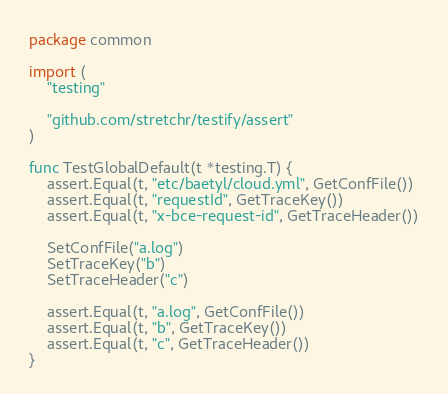Convert code to text. <code><loc_0><loc_0><loc_500><loc_500><_Go_>package common

import (
	"testing"

	"github.com/stretchr/testify/assert"
)

func TestGlobalDefault(t *testing.T) {
	assert.Equal(t, "etc/baetyl/cloud.yml", GetConfFile())
	assert.Equal(t, "requestId", GetTraceKey())
	assert.Equal(t, "x-bce-request-id", GetTraceHeader())

	SetConfFile("a.log")
	SetTraceKey("b")
	SetTraceHeader("c")

	assert.Equal(t, "a.log", GetConfFile())
	assert.Equal(t, "b", GetTraceKey())
	assert.Equal(t, "c", GetTraceHeader())
}
</code> 